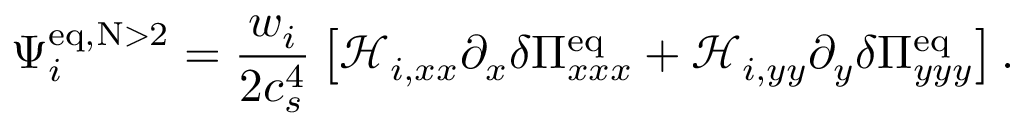<formula> <loc_0><loc_0><loc_500><loc_500>\Psi _ { i } ^ { e q , N > 2 } = \frac { w _ { i } } { 2 c _ { s } ^ { 4 } } \left [ \mathcal { H } _ { i , x x } \partial _ { x } \delta \Pi _ { x x x } ^ { e q } + \mathcal { H } _ { i , y y } \partial _ { y } \delta \Pi _ { y y y } ^ { e q } \right ] .</formula> 